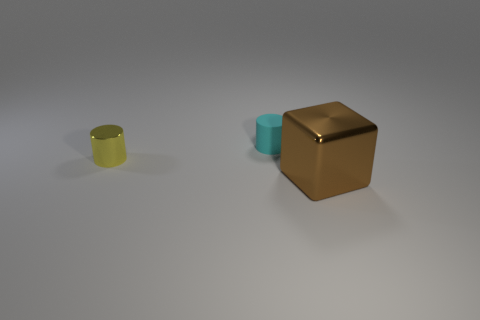Add 3 cyan rubber cylinders. How many objects exist? 6 Subtract all cubes. How many objects are left? 2 Subtract 1 brown cubes. How many objects are left? 2 Subtract all red cylinders. Subtract all gray spheres. How many cylinders are left? 2 Subtract all yellow blocks. How many gray cylinders are left? 0 Subtract all big metallic blocks. Subtract all brown metallic objects. How many objects are left? 1 Add 1 yellow things. How many yellow things are left? 2 Add 2 large cyan matte objects. How many large cyan matte objects exist? 2 Subtract all yellow cylinders. How many cylinders are left? 1 